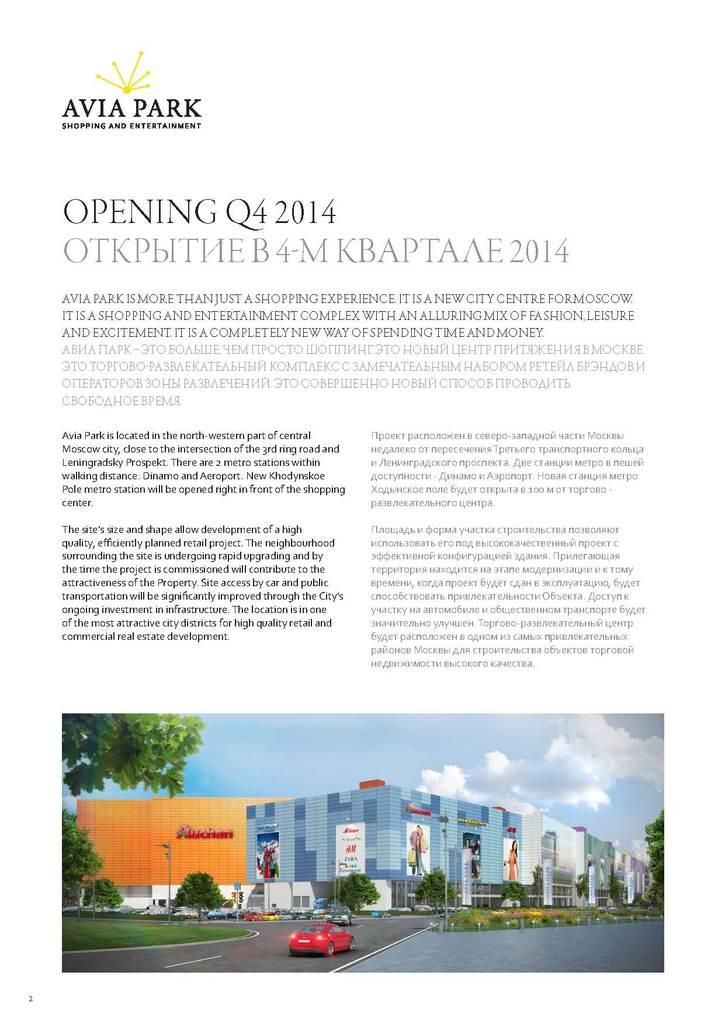What type of structures can be seen in the image? There are buildings in the image. What other objects can be seen in the image besides buildings? There are trees, vehicles, poles, and banners in the image. What is the color of the sky in the image? The sky is white and blue in color. What is the color of the background in the image? The background is white in color. Is there any text visible in the image? Yes, there is text written on the background. Where is the crate of poison located in the image? There is no crate of poison present in the image. What type of lumber is being used to construct the buildings in the image? The image does not provide information about the materials used to construct the buildings. 